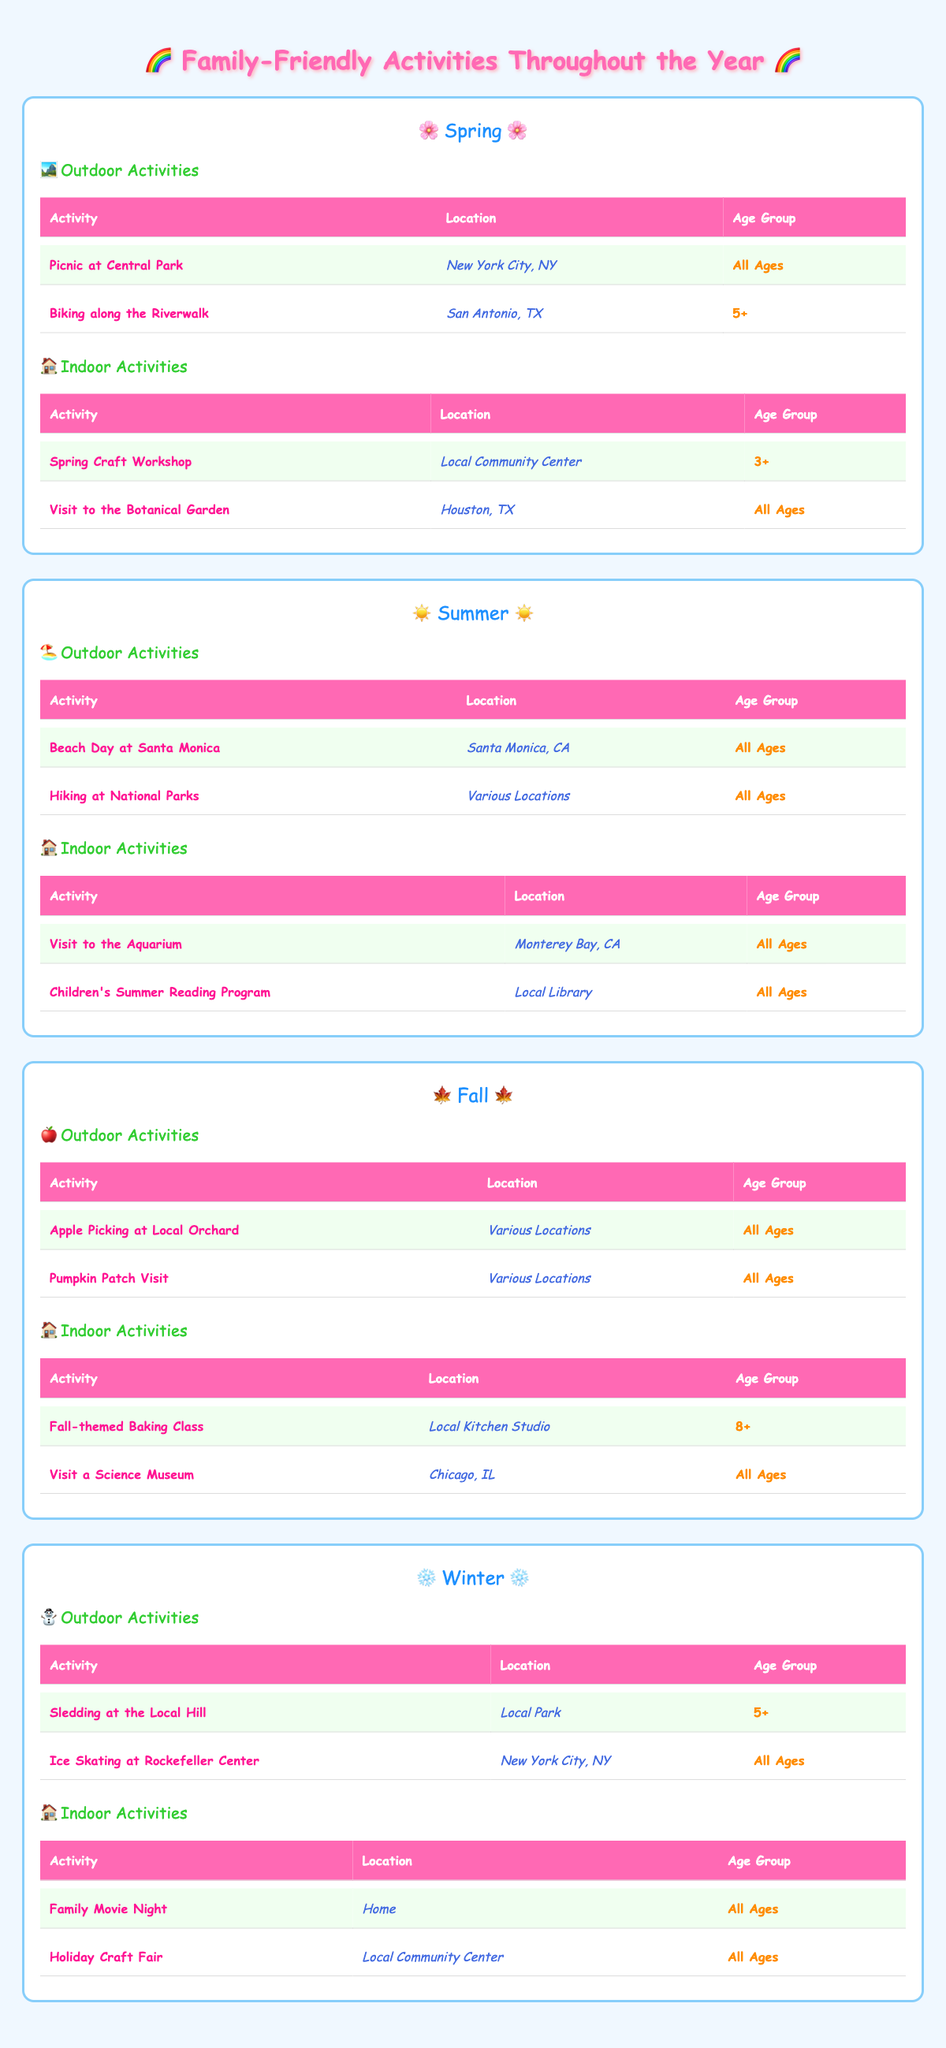What are two outdoor activities available in Spring? From the Spring section of the table, the outdoor activities listed are "Picnic at Central Park" and "Biking along the Riverwalk." Therefore, these are the two outdoor activities available in Spring.
Answer: Picnic at Central Park, Biking along the Riverwalk Is "Family Movie Night" offered in Winter? The table shows that "Family Movie Night" is listed under Winter in the Indoor Activities section. Thus, it confirms that this activity is indeed available in the Winter season.
Answer: Yes How many different locations are mentioned for Fall outdoor activities? The Fall outdoor activities listed are "Apple Picking at Local Orchard" and "Pumpkin Patch Visit." Both activities have "Various Locations" mentioned, indicating only one unique location description, which is counted as one.
Answer: 1 Are any indoor activities in Summer suitable for all ages? In the Summer Indoor Activities section, both "Visit to the Aquarium" and "Children's Summer Reading Program" are categorized as suitable for "All Ages." Therefore, these two indoor activities meet that criterion.
Answer: Yes What is the total number of indoor activities across all seasons? By counting the indoor activities from each season: Spring (2), Summer (2), Fall (2), and Winter (2), the total is calculated as 2 + 2 + 2 + 2 = 8.
Answer: 8 Which season has an outdoor activity suitable for ages 5 and up? In the Winter section, "Sledding at the Local Hill" is the only outdoor activity labeled for ages 5+, indicating it as the specific activity fitting that age group during that season.
Answer: Winter How many different age groups are catered to in the Fall indoor activities? The Fall indoor activities include "Fall-themed Baking Class" suitable for ages 8+ and "Visit a Science Museum" for all ages. This indicates there are two different age group categories represented.
Answer: 2 Which season offers the most outdoor activities? Both Summer and Fall have two outdoor activities listed each, while Spring and Winter offer only two and two respectively. Consequently, Summer and Fall tie as seasons offering the most outdoor activities.
Answer: Summer and Fall 